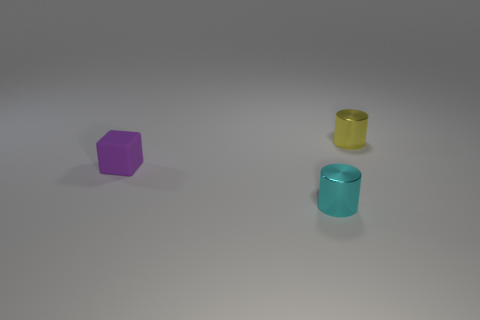Is the number of big red blocks greater than the number of yellow metallic objects?
Make the answer very short. No. There is a small object in front of the matte block; does it have the same shape as the tiny purple thing?
Your answer should be very brief. No. How many matte objects are either yellow things or purple cubes?
Keep it short and to the point. 1. Is there a blue ball that has the same material as the small purple block?
Provide a short and direct response. No. What is the small block made of?
Your answer should be compact. Rubber. There is a rubber thing that is on the left side of the small metal object on the right side of the metal cylinder in front of the small purple rubber cube; what is its shape?
Your response must be concise. Cube. Are there more matte blocks in front of the cyan thing than tiny gray cylinders?
Make the answer very short. No. Does the small matte object have the same shape as the small shiny thing that is in front of the yellow object?
Give a very brief answer. No. What number of small rubber objects are right of the thing left of the cyan cylinder that is in front of the small rubber block?
Your answer should be very brief. 0. There is another shiny cylinder that is the same size as the yellow metallic cylinder; what color is it?
Your answer should be very brief. Cyan. 